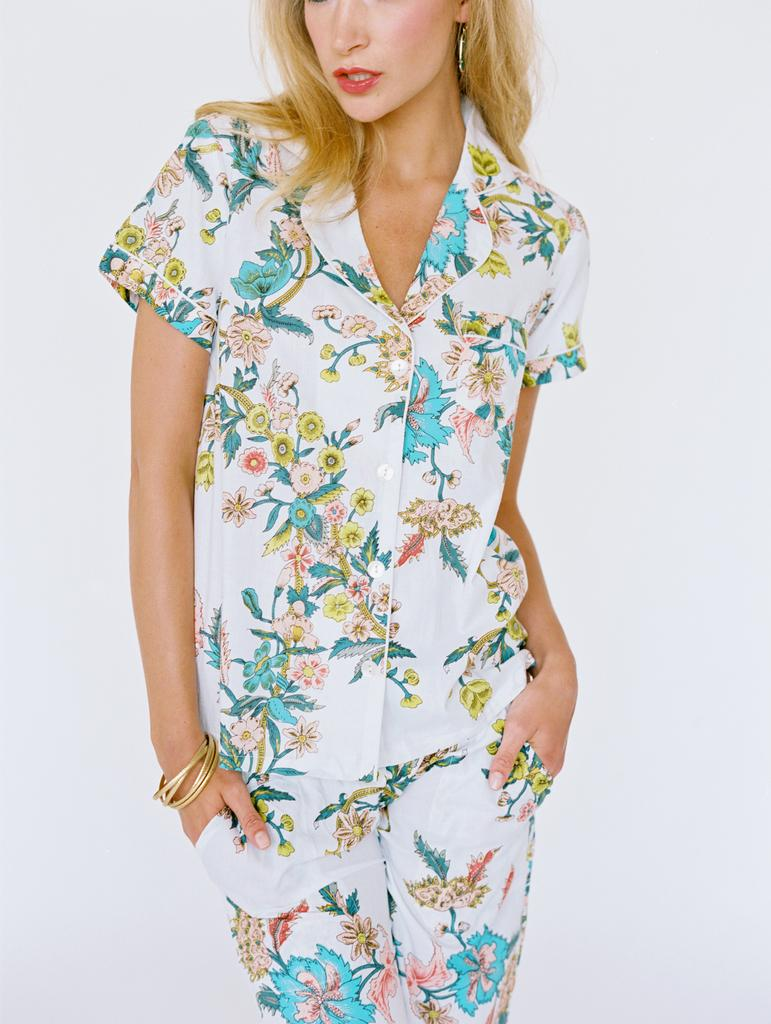Who is the main subject in the image? There is a woman in the image. What is the woman wearing? The woman is wearing a white dress. What is the color of the background in the image? The background of the image is white. What memories does the woman in the image have of her childhood? There is no information about the woman's memories or childhood in the image. 